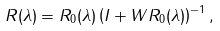<formula> <loc_0><loc_0><loc_500><loc_500>R ( \lambda ) = R _ { 0 } ( \lambda ) \left ( I + W R _ { 0 } ( \lambda ) \right ) ^ { - 1 } ,</formula> 